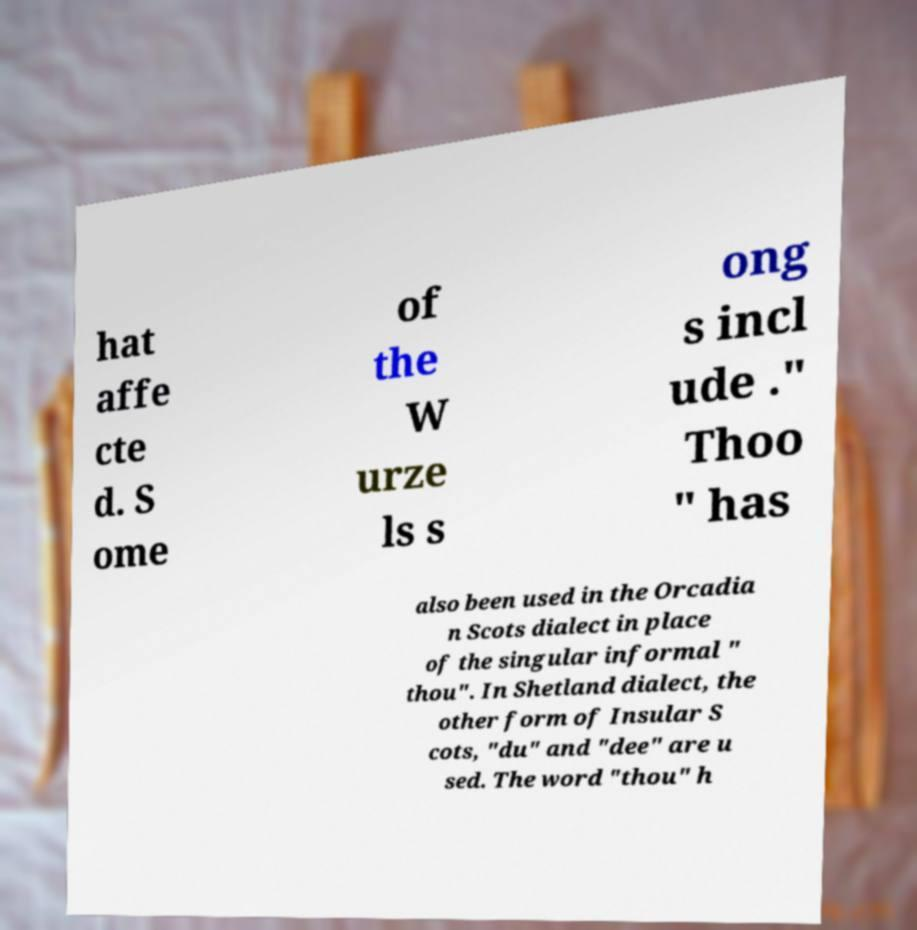What messages or text are displayed in this image? I need them in a readable, typed format. hat affe cte d. S ome of the W urze ls s ong s incl ude ." Thoo " has also been used in the Orcadia n Scots dialect in place of the singular informal " thou". In Shetland dialect, the other form of Insular S cots, "du" and "dee" are u sed. The word "thou" h 